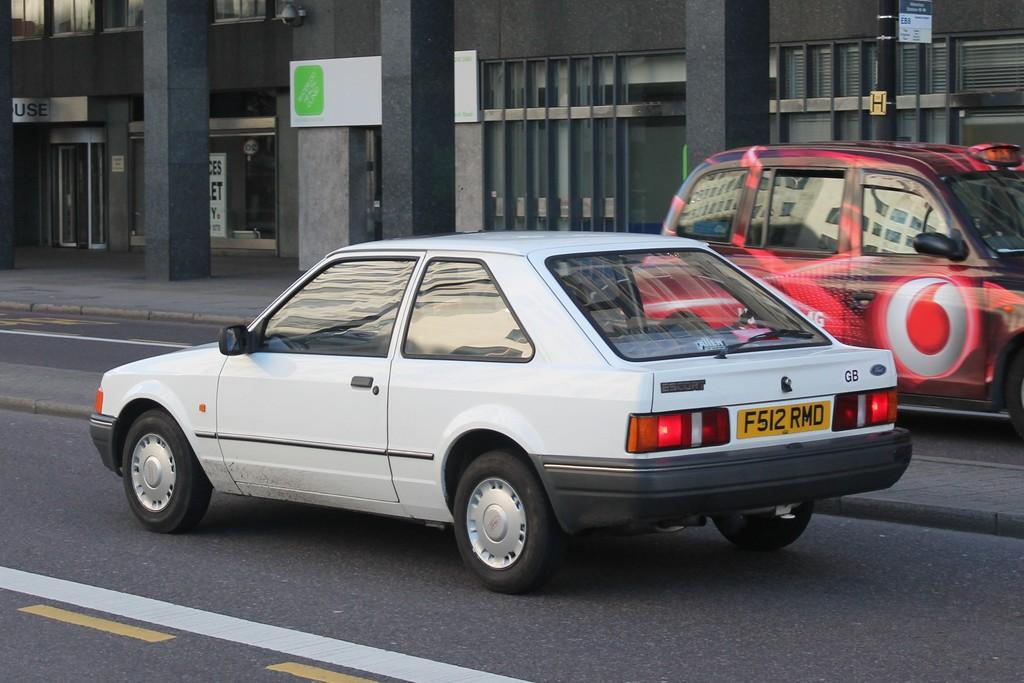What type of structure is visible in the image? There is a building in the image. What is attached to the building? Boards are attached to the building. What other objects can be seen in the image? There are poles and pillars in the image. What is happening in front of the building? Vehicles are present on the road in front of the building. What type of metal is used to construct the marble plantation in the image? There is no metal, marble, or plantation present in the image. 